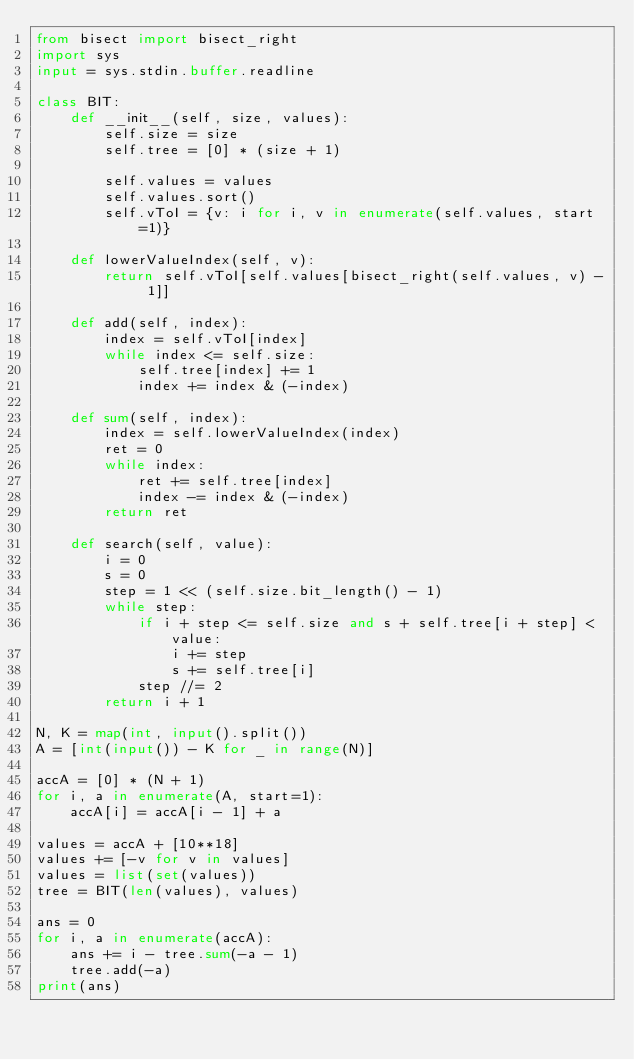Convert code to text. <code><loc_0><loc_0><loc_500><loc_500><_Python_>from bisect import bisect_right
import sys
input = sys.stdin.buffer.readline

class BIT:
    def __init__(self, size, values):
        self.size = size
        self.tree = [0] * (size + 1)

        self.values = values
        self.values.sort()
        self.vToI = {v: i for i, v in enumerate(self.values, start=1)}

    def lowerValueIndex(self, v):
        return self.vToI[self.values[bisect_right(self.values, v) - 1]]

    def add(self, index):
        index = self.vToI[index]
        while index <= self.size:
            self.tree[index] += 1
            index += index & (-index)

    def sum(self, index):
        index = self.lowerValueIndex(index)
        ret = 0
        while index:
            ret += self.tree[index]
            index -= index & (-index)
        return ret

    def search(self, value):
        i = 0
        s = 0
        step = 1 << (self.size.bit_length() - 1)
        while step:
            if i + step <= self.size and s + self.tree[i + step] < value:
                i += step
                s += self.tree[i]
            step //= 2
        return i + 1

N, K = map(int, input().split())
A = [int(input()) - K for _ in range(N)]

accA = [0] * (N + 1)
for i, a in enumerate(A, start=1):
    accA[i] = accA[i - 1] + a

values = accA + [10**18]
values += [-v for v in values]
values = list(set(values))
tree = BIT(len(values), values)

ans = 0
for i, a in enumerate(accA):
    ans += i - tree.sum(-a - 1)
    tree.add(-a)
print(ans)
</code> 